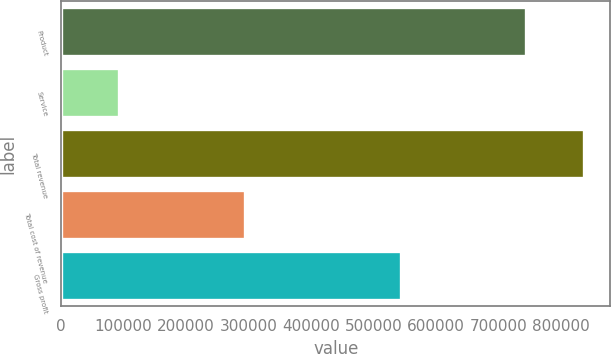<chart> <loc_0><loc_0><loc_500><loc_500><bar_chart><fcel>Product<fcel>Service<fcel>Total revenue<fcel>Total cost of revenue<fcel>Gross profit<nl><fcel>744877<fcel>92714<fcel>837591<fcel>294031<fcel>543560<nl></chart> 